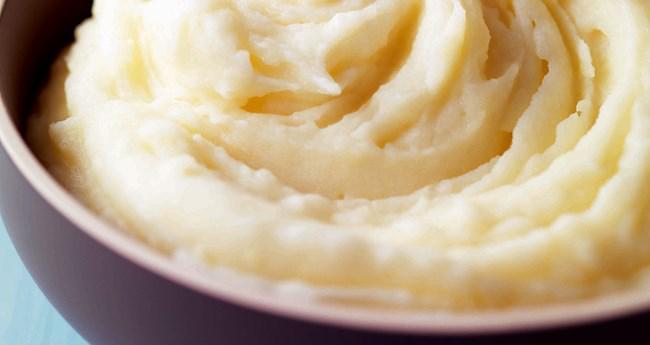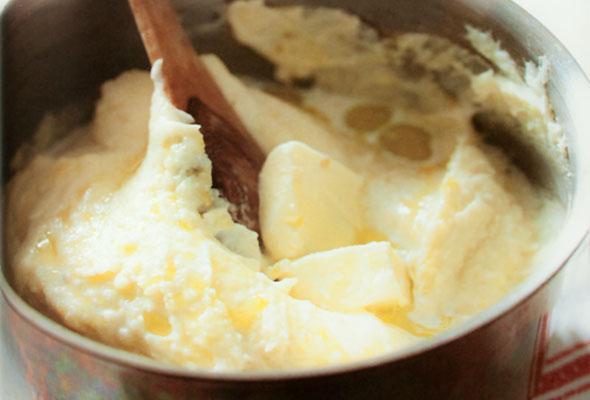The first image is the image on the left, the second image is the image on the right. Assess this claim about the two images: "At least one image shows mashed potatoes served in a white bowl.". Correct or not? Answer yes or no. No. The first image is the image on the left, the second image is the image on the right. Evaluate the accuracy of this statement regarding the images: "At least one bowl is white.". Is it true? Answer yes or no. No. 